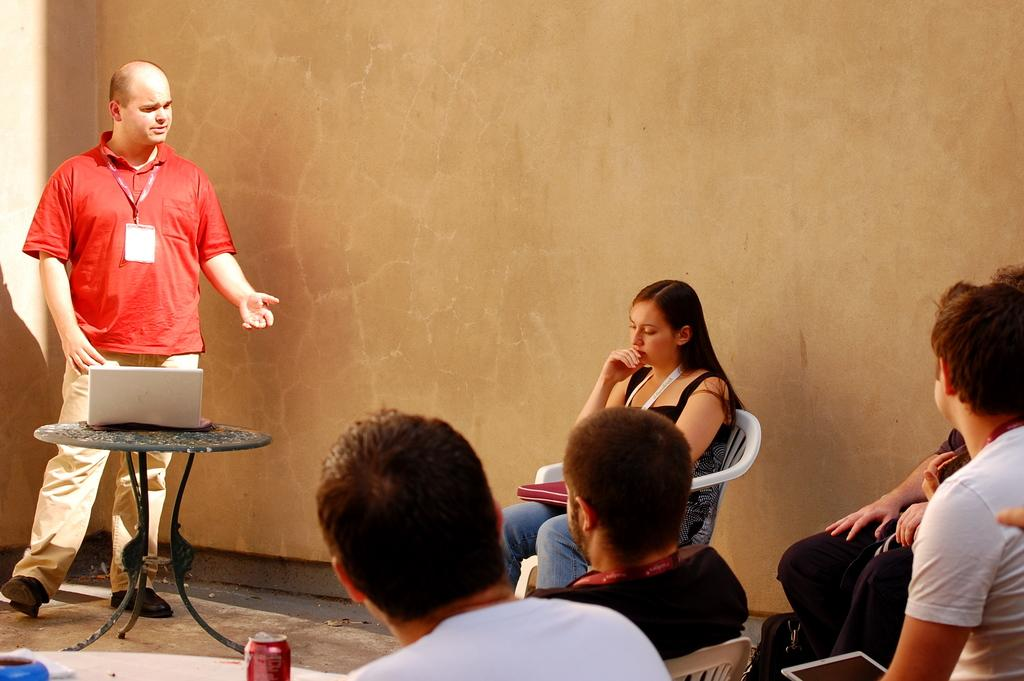What is the man in the image wearing? The man is wearing a red t-shirt. What is the man doing in the image? The man is standing and talking. What object can be seen on a table in the image? There is a laptop on a table in the image. What are some people in the image doing? There are people sitting on chairs in the image. What type of container is present in the image? There is a tin in the image. How does the man control the steam in the image? There is no steam present in the image, so the man cannot control it. 